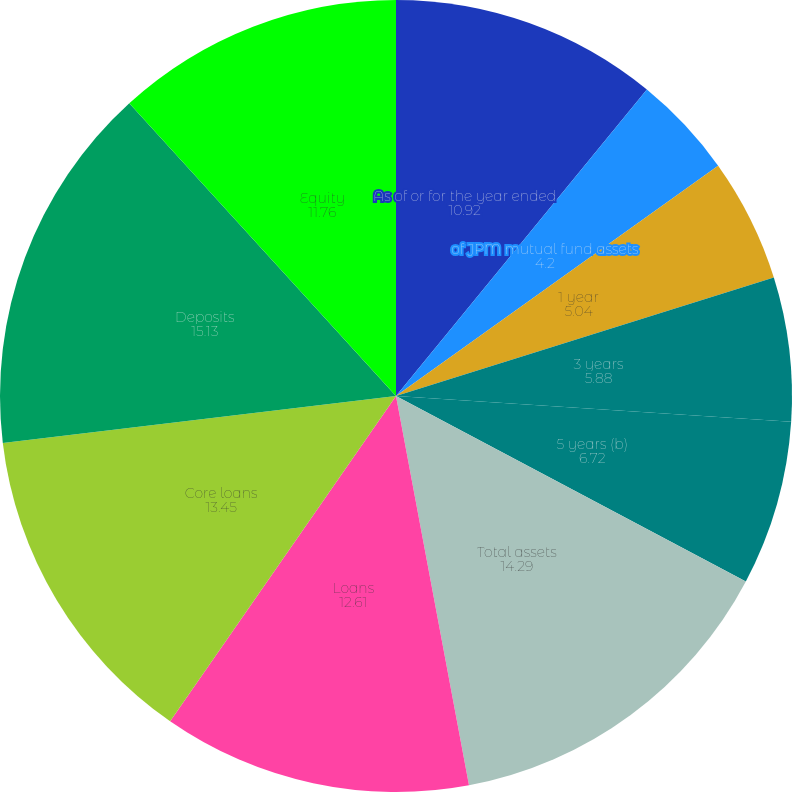<chart> <loc_0><loc_0><loc_500><loc_500><pie_chart><fcel>As of or for the year ended<fcel>of JPM mutual fund assets<fcel>1 year<fcel>3 years<fcel>5 years (b)<fcel>Total assets<fcel>Loans<fcel>Core loans<fcel>Deposits<fcel>Equity<nl><fcel>10.92%<fcel>4.2%<fcel>5.04%<fcel>5.88%<fcel>6.72%<fcel>14.29%<fcel>12.61%<fcel>13.45%<fcel>15.13%<fcel>11.76%<nl></chart> 